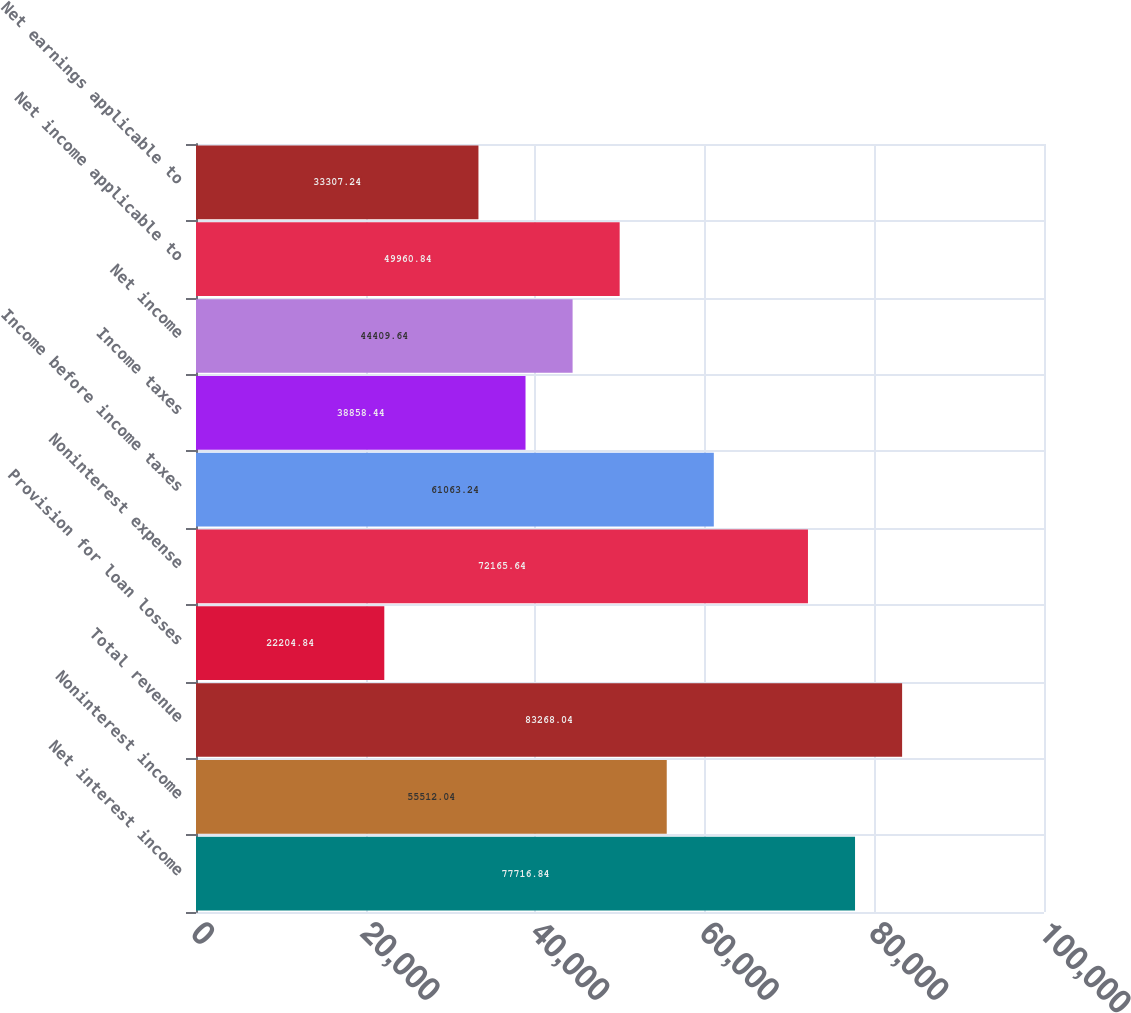Convert chart. <chart><loc_0><loc_0><loc_500><loc_500><bar_chart><fcel>Net interest income<fcel>Noninterest income<fcel>Total revenue<fcel>Provision for loan losses<fcel>Noninterest expense<fcel>Income before income taxes<fcel>Income taxes<fcel>Net income<fcel>Net income applicable to<fcel>Net earnings applicable to<nl><fcel>77716.8<fcel>55512<fcel>83268<fcel>22204.8<fcel>72165.6<fcel>61063.2<fcel>38858.4<fcel>44409.6<fcel>49960.8<fcel>33307.2<nl></chart> 